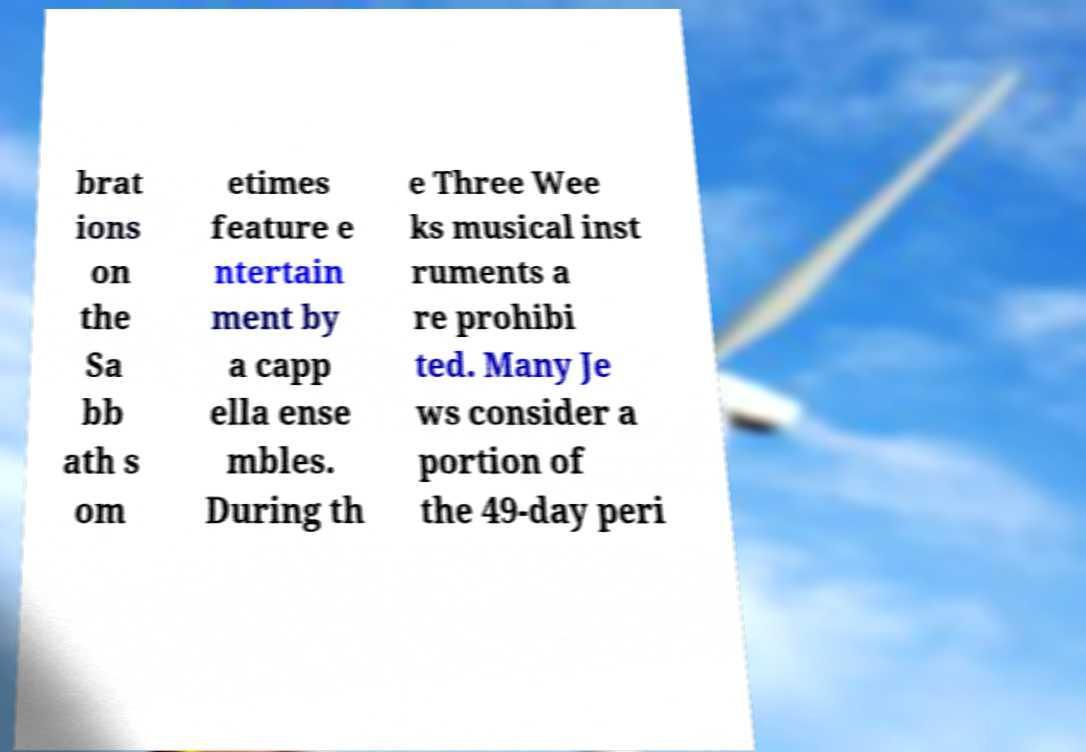I need the written content from this picture converted into text. Can you do that? brat ions on the Sa bb ath s om etimes feature e ntertain ment by a capp ella ense mbles. During th e Three Wee ks musical inst ruments a re prohibi ted. Many Je ws consider a portion of the 49-day peri 